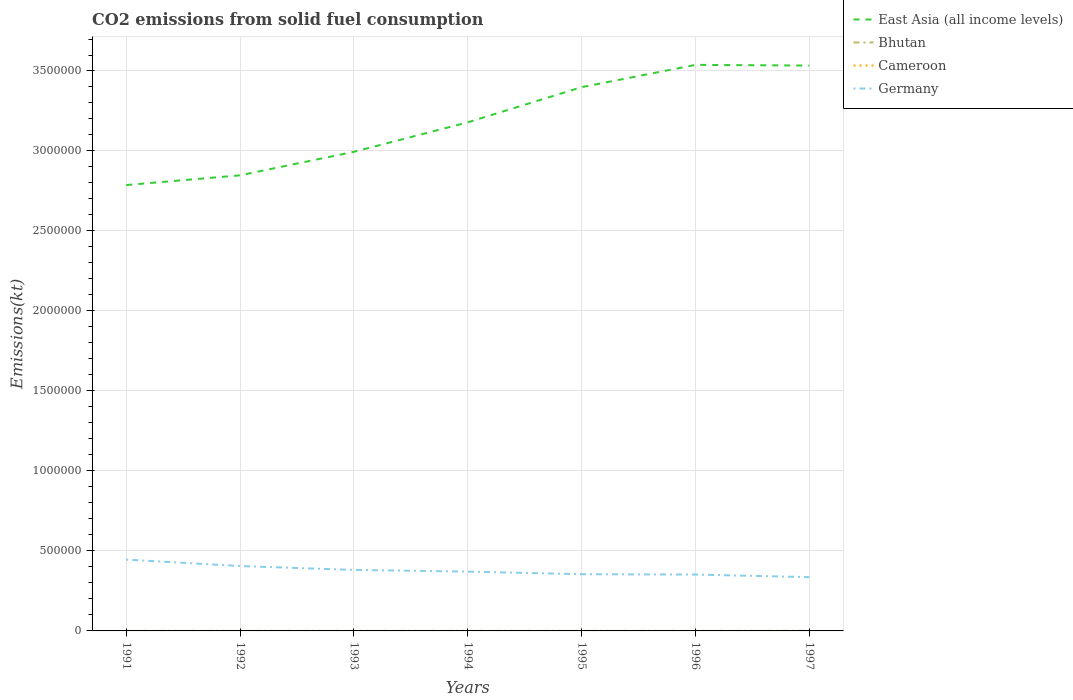Does the line corresponding to Cameroon intersect with the line corresponding to Bhutan?
Provide a short and direct response. No. Is the number of lines equal to the number of legend labels?
Provide a succinct answer. Yes. Across all years, what is the maximum amount of CO2 emitted in Cameroon?
Ensure brevity in your answer.  3.67. What is the total amount of CO2 emitted in Germany in the graph?
Your response must be concise. 2.67e+04. What is the difference between the highest and the second highest amount of CO2 emitted in Cameroon?
Ensure brevity in your answer.  0. Is the amount of CO2 emitted in Cameroon strictly greater than the amount of CO2 emitted in Germany over the years?
Offer a very short reply. Yes. How many lines are there?
Offer a very short reply. 4. What is the difference between two consecutive major ticks on the Y-axis?
Offer a very short reply. 5.00e+05. Does the graph contain any zero values?
Your answer should be very brief. No. Does the graph contain grids?
Your answer should be compact. Yes. What is the title of the graph?
Offer a very short reply. CO2 emissions from solid fuel consumption. Does "Guinea" appear as one of the legend labels in the graph?
Give a very brief answer. No. What is the label or title of the Y-axis?
Give a very brief answer. Emissions(kt). What is the Emissions(kt) in East Asia (all income levels) in 1991?
Your answer should be compact. 2.79e+06. What is the Emissions(kt) in Bhutan in 1991?
Offer a very short reply. 47.67. What is the Emissions(kt) of Cameroon in 1991?
Provide a succinct answer. 3.67. What is the Emissions(kt) in Germany in 1991?
Ensure brevity in your answer.  4.46e+05. What is the Emissions(kt) of East Asia (all income levels) in 1992?
Your response must be concise. 2.85e+06. What is the Emissions(kt) in Bhutan in 1992?
Your answer should be compact. 80.67. What is the Emissions(kt) in Cameroon in 1992?
Ensure brevity in your answer.  3.67. What is the Emissions(kt) of Germany in 1992?
Ensure brevity in your answer.  4.06e+05. What is the Emissions(kt) of East Asia (all income levels) in 1993?
Make the answer very short. 3.00e+06. What is the Emissions(kt) in Bhutan in 1993?
Your answer should be compact. 44. What is the Emissions(kt) in Cameroon in 1993?
Provide a short and direct response. 3.67. What is the Emissions(kt) of Germany in 1993?
Provide a succinct answer. 3.81e+05. What is the Emissions(kt) of East Asia (all income levels) in 1994?
Give a very brief answer. 3.18e+06. What is the Emissions(kt) in Bhutan in 1994?
Give a very brief answer. 62.34. What is the Emissions(kt) of Cameroon in 1994?
Offer a terse response. 3.67. What is the Emissions(kt) in Germany in 1994?
Keep it short and to the point. 3.71e+05. What is the Emissions(kt) in East Asia (all income levels) in 1995?
Offer a very short reply. 3.40e+06. What is the Emissions(kt) in Bhutan in 1995?
Offer a terse response. 77.01. What is the Emissions(kt) of Cameroon in 1995?
Make the answer very short. 3.67. What is the Emissions(kt) of Germany in 1995?
Offer a very short reply. 3.55e+05. What is the Emissions(kt) of East Asia (all income levels) in 1996?
Your answer should be compact. 3.54e+06. What is the Emissions(kt) of Bhutan in 1996?
Give a very brief answer. 91.67. What is the Emissions(kt) in Cameroon in 1996?
Keep it short and to the point. 3.67. What is the Emissions(kt) in Germany in 1996?
Make the answer very short. 3.52e+05. What is the Emissions(kt) in East Asia (all income levels) in 1997?
Ensure brevity in your answer.  3.53e+06. What is the Emissions(kt) of Bhutan in 1997?
Make the answer very short. 187.02. What is the Emissions(kt) in Cameroon in 1997?
Give a very brief answer. 3.67. What is the Emissions(kt) in Germany in 1997?
Keep it short and to the point. 3.36e+05. Across all years, what is the maximum Emissions(kt) of East Asia (all income levels)?
Give a very brief answer. 3.54e+06. Across all years, what is the maximum Emissions(kt) of Bhutan?
Your response must be concise. 187.02. Across all years, what is the maximum Emissions(kt) in Cameroon?
Offer a terse response. 3.67. Across all years, what is the maximum Emissions(kt) of Germany?
Offer a terse response. 4.46e+05. Across all years, what is the minimum Emissions(kt) in East Asia (all income levels)?
Offer a very short reply. 2.79e+06. Across all years, what is the minimum Emissions(kt) of Bhutan?
Your response must be concise. 44. Across all years, what is the minimum Emissions(kt) of Cameroon?
Your answer should be very brief. 3.67. Across all years, what is the minimum Emissions(kt) in Germany?
Your answer should be very brief. 3.36e+05. What is the total Emissions(kt) of East Asia (all income levels) in the graph?
Give a very brief answer. 2.23e+07. What is the total Emissions(kt) of Bhutan in the graph?
Make the answer very short. 590.39. What is the total Emissions(kt) of Cameroon in the graph?
Give a very brief answer. 25.67. What is the total Emissions(kt) of Germany in the graph?
Ensure brevity in your answer.  2.65e+06. What is the difference between the Emissions(kt) of East Asia (all income levels) in 1991 and that in 1992?
Your response must be concise. -6.08e+04. What is the difference between the Emissions(kt) in Bhutan in 1991 and that in 1992?
Offer a very short reply. -33. What is the difference between the Emissions(kt) of Germany in 1991 and that in 1992?
Your answer should be very brief. 4.02e+04. What is the difference between the Emissions(kt) in East Asia (all income levels) in 1991 and that in 1993?
Offer a very short reply. -2.08e+05. What is the difference between the Emissions(kt) of Bhutan in 1991 and that in 1993?
Keep it short and to the point. 3.67. What is the difference between the Emissions(kt) of Germany in 1991 and that in 1993?
Your response must be concise. 6.46e+04. What is the difference between the Emissions(kt) in East Asia (all income levels) in 1991 and that in 1994?
Make the answer very short. -3.92e+05. What is the difference between the Emissions(kt) of Bhutan in 1991 and that in 1994?
Give a very brief answer. -14.67. What is the difference between the Emissions(kt) in Germany in 1991 and that in 1994?
Your answer should be very brief. 7.50e+04. What is the difference between the Emissions(kt) of East Asia (all income levels) in 1991 and that in 1995?
Provide a succinct answer. -6.12e+05. What is the difference between the Emissions(kt) of Bhutan in 1991 and that in 1995?
Provide a short and direct response. -29.34. What is the difference between the Emissions(kt) in Cameroon in 1991 and that in 1995?
Your answer should be very brief. 0. What is the difference between the Emissions(kt) in Germany in 1991 and that in 1995?
Make the answer very short. 9.13e+04. What is the difference between the Emissions(kt) of East Asia (all income levels) in 1991 and that in 1996?
Provide a succinct answer. -7.51e+05. What is the difference between the Emissions(kt) of Bhutan in 1991 and that in 1996?
Provide a succinct answer. -44. What is the difference between the Emissions(kt) of Germany in 1991 and that in 1996?
Provide a short and direct response. 9.35e+04. What is the difference between the Emissions(kt) of East Asia (all income levels) in 1991 and that in 1997?
Provide a short and direct response. -7.47e+05. What is the difference between the Emissions(kt) of Bhutan in 1991 and that in 1997?
Provide a succinct answer. -139.35. What is the difference between the Emissions(kt) in Germany in 1991 and that in 1997?
Offer a very short reply. 1.10e+05. What is the difference between the Emissions(kt) in East Asia (all income levels) in 1992 and that in 1993?
Give a very brief answer. -1.47e+05. What is the difference between the Emissions(kt) in Bhutan in 1992 and that in 1993?
Offer a terse response. 36.67. What is the difference between the Emissions(kt) in Cameroon in 1992 and that in 1993?
Your answer should be very brief. 0. What is the difference between the Emissions(kt) of Germany in 1992 and that in 1993?
Your answer should be very brief. 2.44e+04. What is the difference between the Emissions(kt) of East Asia (all income levels) in 1992 and that in 1994?
Your response must be concise. -3.31e+05. What is the difference between the Emissions(kt) in Bhutan in 1992 and that in 1994?
Provide a short and direct response. 18.34. What is the difference between the Emissions(kt) in Germany in 1992 and that in 1994?
Your response must be concise. 3.48e+04. What is the difference between the Emissions(kt) in East Asia (all income levels) in 1992 and that in 1995?
Your answer should be very brief. -5.51e+05. What is the difference between the Emissions(kt) of Bhutan in 1992 and that in 1995?
Your answer should be compact. 3.67. What is the difference between the Emissions(kt) in Cameroon in 1992 and that in 1995?
Provide a succinct answer. 0. What is the difference between the Emissions(kt) of Germany in 1992 and that in 1995?
Offer a terse response. 5.10e+04. What is the difference between the Emissions(kt) of East Asia (all income levels) in 1992 and that in 1996?
Offer a very short reply. -6.90e+05. What is the difference between the Emissions(kt) of Bhutan in 1992 and that in 1996?
Keep it short and to the point. -11. What is the difference between the Emissions(kt) of Cameroon in 1992 and that in 1996?
Your answer should be compact. 0. What is the difference between the Emissions(kt) in Germany in 1992 and that in 1996?
Make the answer very short. 5.33e+04. What is the difference between the Emissions(kt) of East Asia (all income levels) in 1992 and that in 1997?
Keep it short and to the point. -6.86e+05. What is the difference between the Emissions(kt) of Bhutan in 1992 and that in 1997?
Your response must be concise. -106.34. What is the difference between the Emissions(kt) in Cameroon in 1992 and that in 1997?
Provide a short and direct response. 0. What is the difference between the Emissions(kt) in Germany in 1992 and that in 1997?
Make the answer very short. 6.94e+04. What is the difference between the Emissions(kt) in East Asia (all income levels) in 1993 and that in 1994?
Offer a very short reply. -1.84e+05. What is the difference between the Emissions(kt) of Bhutan in 1993 and that in 1994?
Your answer should be compact. -18.34. What is the difference between the Emissions(kt) of Cameroon in 1993 and that in 1994?
Provide a succinct answer. 0. What is the difference between the Emissions(kt) of Germany in 1993 and that in 1994?
Your answer should be very brief. 1.04e+04. What is the difference between the Emissions(kt) of East Asia (all income levels) in 1993 and that in 1995?
Offer a very short reply. -4.04e+05. What is the difference between the Emissions(kt) in Bhutan in 1993 and that in 1995?
Offer a very short reply. -33. What is the difference between the Emissions(kt) in Germany in 1993 and that in 1995?
Ensure brevity in your answer.  2.67e+04. What is the difference between the Emissions(kt) of East Asia (all income levels) in 1993 and that in 1996?
Provide a short and direct response. -5.43e+05. What is the difference between the Emissions(kt) in Bhutan in 1993 and that in 1996?
Offer a terse response. -47.67. What is the difference between the Emissions(kt) of Cameroon in 1993 and that in 1996?
Your answer should be very brief. 0. What is the difference between the Emissions(kt) in Germany in 1993 and that in 1996?
Provide a succinct answer. 2.89e+04. What is the difference between the Emissions(kt) of East Asia (all income levels) in 1993 and that in 1997?
Provide a succinct answer. -5.39e+05. What is the difference between the Emissions(kt) in Bhutan in 1993 and that in 1997?
Your answer should be compact. -143.01. What is the difference between the Emissions(kt) in Cameroon in 1993 and that in 1997?
Provide a short and direct response. 0. What is the difference between the Emissions(kt) of Germany in 1993 and that in 1997?
Provide a short and direct response. 4.51e+04. What is the difference between the Emissions(kt) of East Asia (all income levels) in 1994 and that in 1995?
Your answer should be very brief. -2.20e+05. What is the difference between the Emissions(kt) of Bhutan in 1994 and that in 1995?
Your response must be concise. -14.67. What is the difference between the Emissions(kt) in Germany in 1994 and that in 1995?
Ensure brevity in your answer.  1.62e+04. What is the difference between the Emissions(kt) in East Asia (all income levels) in 1994 and that in 1996?
Keep it short and to the point. -3.59e+05. What is the difference between the Emissions(kt) in Bhutan in 1994 and that in 1996?
Offer a very short reply. -29.34. What is the difference between the Emissions(kt) of Germany in 1994 and that in 1996?
Your response must be concise. 1.85e+04. What is the difference between the Emissions(kt) of East Asia (all income levels) in 1994 and that in 1997?
Offer a very short reply. -3.55e+05. What is the difference between the Emissions(kt) of Bhutan in 1994 and that in 1997?
Ensure brevity in your answer.  -124.68. What is the difference between the Emissions(kt) of Germany in 1994 and that in 1997?
Your response must be concise. 3.46e+04. What is the difference between the Emissions(kt) in East Asia (all income levels) in 1995 and that in 1996?
Provide a short and direct response. -1.39e+05. What is the difference between the Emissions(kt) in Bhutan in 1995 and that in 1996?
Your answer should be very brief. -14.67. What is the difference between the Emissions(kt) of Germany in 1995 and that in 1996?
Ensure brevity in your answer.  2244.2. What is the difference between the Emissions(kt) in East Asia (all income levels) in 1995 and that in 1997?
Provide a succinct answer. -1.35e+05. What is the difference between the Emissions(kt) of Bhutan in 1995 and that in 1997?
Make the answer very short. -110.01. What is the difference between the Emissions(kt) in Germany in 1995 and that in 1997?
Your answer should be compact. 1.84e+04. What is the difference between the Emissions(kt) of East Asia (all income levels) in 1996 and that in 1997?
Your answer should be compact. 4301.22. What is the difference between the Emissions(kt) in Bhutan in 1996 and that in 1997?
Your answer should be very brief. -95.34. What is the difference between the Emissions(kt) of Germany in 1996 and that in 1997?
Give a very brief answer. 1.62e+04. What is the difference between the Emissions(kt) in East Asia (all income levels) in 1991 and the Emissions(kt) in Bhutan in 1992?
Your answer should be very brief. 2.79e+06. What is the difference between the Emissions(kt) of East Asia (all income levels) in 1991 and the Emissions(kt) of Cameroon in 1992?
Offer a very short reply. 2.79e+06. What is the difference between the Emissions(kt) in East Asia (all income levels) in 1991 and the Emissions(kt) in Germany in 1992?
Provide a short and direct response. 2.38e+06. What is the difference between the Emissions(kt) of Bhutan in 1991 and the Emissions(kt) of Cameroon in 1992?
Your answer should be compact. 44. What is the difference between the Emissions(kt) in Bhutan in 1991 and the Emissions(kt) in Germany in 1992?
Your response must be concise. -4.06e+05. What is the difference between the Emissions(kt) in Cameroon in 1991 and the Emissions(kt) in Germany in 1992?
Provide a succinct answer. -4.06e+05. What is the difference between the Emissions(kt) of East Asia (all income levels) in 1991 and the Emissions(kt) of Bhutan in 1993?
Offer a terse response. 2.79e+06. What is the difference between the Emissions(kt) of East Asia (all income levels) in 1991 and the Emissions(kt) of Cameroon in 1993?
Keep it short and to the point. 2.79e+06. What is the difference between the Emissions(kt) in East Asia (all income levels) in 1991 and the Emissions(kt) in Germany in 1993?
Your answer should be very brief. 2.41e+06. What is the difference between the Emissions(kt) in Bhutan in 1991 and the Emissions(kt) in Cameroon in 1993?
Your answer should be very brief. 44. What is the difference between the Emissions(kt) of Bhutan in 1991 and the Emissions(kt) of Germany in 1993?
Your response must be concise. -3.81e+05. What is the difference between the Emissions(kt) of Cameroon in 1991 and the Emissions(kt) of Germany in 1993?
Offer a terse response. -3.81e+05. What is the difference between the Emissions(kt) of East Asia (all income levels) in 1991 and the Emissions(kt) of Bhutan in 1994?
Give a very brief answer. 2.79e+06. What is the difference between the Emissions(kt) in East Asia (all income levels) in 1991 and the Emissions(kt) in Cameroon in 1994?
Provide a succinct answer. 2.79e+06. What is the difference between the Emissions(kt) of East Asia (all income levels) in 1991 and the Emissions(kt) of Germany in 1994?
Keep it short and to the point. 2.42e+06. What is the difference between the Emissions(kt) of Bhutan in 1991 and the Emissions(kt) of Cameroon in 1994?
Your response must be concise. 44. What is the difference between the Emissions(kt) in Bhutan in 1991 and the Emissions(kt) in Germany in 1994?
Your answer should be compact. -3.71e+05. What is the difference between the Emissions(kt) of Cameroon in 1991 and the Emissions(kt) of Germany in 1994?
Your response must be concise. -3.71e+05. What is the difference between the Emissions(kt) in East Asia (all income levels) in 1991 and the Emissions(kt) in Bhutan in 1995?
Give a very brief answer. 2.79e+06. What is the difference between the Emissions(kt) in East Asia (all income levels) in 1991 and the Emissions(kt) in Cameroon in 1995?
Your answer should be very brief. 2.79e+06. What is the difference between the Emissions(kt) of East Asia (all income levels) in 1991 and the Emissions(kt) of Germany in 1995?
Offer a very short reply. 2.43e+06. What is the difference between the Emissions(kt) in Bhutan in 1991 and the Emissions(kt) in Cameroon in 1995?
Keep it short and to the point. 44. What is the difference between the Emissions(kt) in Bhutan in 1991 and the Emissions(kt) in Germany in 1995?
Offer a terse response. -3.54e+05. What is the difference between the Emissions(kt) of Cameroon in 1991 and the Emissions(kt) of Germany in 1995?
Offer a terse response. -3.55e+05. What is the difference between the Emissions(kt) in East Asia (all income levels) in 1991 and the Emissions(kt) in Bhutan in 1996?
Make the answer very short. 2.79e+06. What is the difference between the Emissions(kt) in East Asia (all income levels) in 1991 and the Emissions(kt) in Cameroon in 1996?
Offer a very short reply. 2.79e+06. What is the difference between the Emissions(kt) in East Asia (all income levels) in 1991 and the Emissions(kt) in Germany in 1996?
Your answer should be very brief. 2.43e+06. What is the difference between the Emissions(kt) of Bhutan in 1991 and the Emissions(kt) of Cameroon in 1996?
Your answer should be very brief. 44. What is the difference between the Emissions(kt) of Bhutan in 1991 and the Emissions(kt) of Germany in 1996?
Offer a terse response. -3.52e+05. What is the difference between the Emissions(kt) of Cameroon in 1991 and the Emissions(kt) of Germany in 1996?
Offer a very short reply. -3.52e+05. What is the difference between the Emissions(kt) of East Asia (all income levels) in 1991 and the Emissions(kt) of Bhutan in 1997?
Offer a terse response. 2.79e+06. What is the difference between the Emissions(kt) of East Asia (all income levels) in 1991 and the Emissions(kt) of Cameroon in 1997?
Provide a succinct answer. 2.79e+06. What is the difference between the Emissions(kt) in East Asia (all income levels) in 1991 and the Emissions(kt) in Germany in 1997?
Your answer should be very brief. 2.45e+06. What is the difference between the Emissions(kt) of Bhutan in 1991 and the Emissions(kt) of Cameroon in 1997?
Offer a very short reply. 44. What is the difference between the Emissions(kt) in Bhutan in 1991 and the Emissions(kt) in Germany in 1997?
Offer a terse response. -3.36e+05. What is the difference between the Emissions(kt) in Cameroon in 1991 and the Emissions(kt) in Germany in 1997?
Your answer should be compact. -3.36e+05. What is the difference between the Emissions(kt) of East Asia (all income levels) in 1992 and the Emissions(kt) of Bhutan in 1993?
Provide a succinct answer. 2.85e+06. What is the difference between the Emissions(kt) of East Asia (all income levels) in 1992 and the Emissions(kt) of Cameroon in 1993?
Your answer should be compact. 2.85e+06. What is the difference between the Emissions(kt) of East Asia (all income levels) in 1992 and the Emissions(kt) of Germany in 1993?
Ensure brevity in your answer.  2.47e+06. What is the difference between the Emissions(kt) in Bhutan in 1992 and the Emissions(kt) in Cameroon in 1993?
Your answer should be compact. 77.01. What is the difference between the Emissions(kt) of Bhutan in 1992 and the Emissions(kt) of Germany in 1993?
Provide a succinct answer. -3.81e+05. What is the difference between the Emissions(kt) in Cameroon in 1992 and the Emissions(kt) in Germany in 1993?
Offer a very short reply. -3.81e+05. What is the difference between the Emissions(kt) of East Asia (all income levels) in 1992 and the Emissions(kt) of Bhutan in 1994?
Give a very brief answer. 2.85e+06. What is the difference between the Emissions(kt) of East Asia (all income levels) in 1992 and the Emissions(kt) of Cameroon in 1994?
Make the answer very short. 2.85e+06. What is the difference between the Emissions(kt) in East Asia (all income levels) in 1992 and the Emissions(kt) in Germany in 1994?
Make the answer very short. 2.48e+06. What is the difference between the Emissions(kt) in Bhutan in 1992 and the Emissions(kt) in Cameroon in 1994?
Your answer should be compact. 77.01. What is the difference between the Emissions(kt) of Bhutan in 1992 and the Emissions(kt) of Germany in 1994?
Offer a terse response. -3.71e+05. What is the difference between the Emissions(kt) of Cameroon in 1992 and the Emissions(kt) of Germany in 1994?
Offer a very short reply. -3.71e+05. What is the difference between the Emissions(kt) in East Asia (all income levels) in 1992 and the Emissions(kt) in Bhutan in 1995?
Offer a very short reply. 2.85e+06. What is the difference between the Emissions(kt) of East Asia (all income levels) in 1992 and the Emissions(kt) of Cameroon in 1995?
Give a very brief answer. 2.85e+06. What is the difference between the Emissions(kt) in East Asia (all income levels) in 1992 and the Emissions(kt) in Germany in 1995?
Offer a terse response. 2.49e+06. What is the difference between the Emissions(kt) in Bhutan in 1992 and the Emissions(kt) in Cameroon in 1995?
Ensure brevity in your answer.  77.01. What is the difference between the Emissions(kt) of Bhutan in 1992 and the Emissions(kt) of Germany in 1995?
Offer a terse response. -3.54e+05. What is the difference between the Emissions(kt) in Cameroon in 1992 and the Emissions(kt) in Germany in 1995?
Your answer should be very brief. -3.55e+05. What is the difference between the Emissions(kt) in East Asia (all income levels) in 1992 and the Emissions(kt) in Bhutan in 1996?
Make the answer very short. 2.85e+06. What is the difference between the Emissions(kt) of East Asia (all income levels) in 1992 and the Emissions(kt) of Cameroon in 1996?
Provide a short and direct response. 2.85e+06. What is the difference between the Emissions(kt) of East Asia (all income levels) in 1992 and the Emissions(kt) of Germany in 1996?
Give a very brief answer. 2.50e+06. What is the difference between the Emissions(kt) in Bhutan in 1992 and the Emissions(kt) in Cameroon in 1996?
Provide a succinct answer. 77.01. What is the difference between the Emissions(kt) in Bhutan in 1992 and the Emissions(kt) in Germany in 1996?
Your answer should be very brief. -3.52e+05. What is the difference between the Emissions(kt) of Cameroon in 1992 and the Emissions(kt) of Germany in 1996?
Offer a terse response. -3.52e+05. What is the difference between the Emissions(kt) in East Asia (all income levels) in 1992 and the Emissions(kt) in Bhutan in 1997?
Your response must be concise. 2.85e+06. What is the difference between the Emissions(kt) in East Asia (all income levels) in 1992 and the Emissions(kt) in Cameroon in 1997?
Your answer should be compact. 2.85e+06. What is the difference between the Emissions(kt) in East Asia (all income levels) in 1992 and the Emissions(kt) in Germany in 1997?
Ensure brevity in your answer.  2.51e+06. What is the difference between the Emissions(kt) of Bhutan in 1992 and the Emissions(kt) of Cameroon in 1997?
Make the answer very short. 77.01. What is the difference between the Emissions(kt) of Bhutan in 1992 and the Emissions(kt) of Germany in 1997?
Your answer should be compact. -3.36e+05. What is the difference between the Emissions(kt) of Cameroon in 1992 and the Emissions(kt) of Germany in 1997?
Give a very brief answer. -3.36e+05. What is the difference between the Emissions(kt) in East Asia (all income levels) in 1993 and the Emissions(kt) in Bhutan in 1994?
Your response must be concise. 2.99e+06. What is the difference between the Emissions(kt) of East Asia (all income levels) in 1993 and the Emissions(kt) of Cameroon in 1994?
Your answer should be very brief. 2.99e+06. What is the difference between the Emissions(kt) in East Asia (all income levels) in 1993 and the Emissions(kt) in Germany in 1994?
Offer a very short reply. 2.62e+06. What is the difference between the Emissions(kt) of Bhutan in 1993 and the Emissions(kt) of Cameroon in 1994?
Make the answer very short. 40.34. What is the difference between the Emissions(kt) in Bhutan in 1993 and the Emissions(kt) in Germany in 1994?
Your response must be concise. -3.71e+05. What is the difference between the Emissions(kt) of Cameroon in 1993 and the Emissions(kt) of Germany in 1994?
Offer a very short reply. -3.71e+05. What is the difference between the Emissions(kt) of East Asia (all income levels) in 1993 and the Emissions(kt) of Bhutan in 1995?
Make the answer very short. 2.99e+06. What is the difference between the Emissions(kt) in East Asia (all income levels) in 1993 and the Emissions(kt) in Cameroon in 1995?
Give a very brief answer. 2.99e+06. What is the difference between the Emissions(kt) of East Asia (all income levels) in 1993 and the Emissions(kt) of Germany in 1995?
Offer a very short reply. 2.64e+06. What is the difference between the Emissions(kt) of Bhutan in 1993 and the Emissions(kt) of Cameroon in 1995?
Ensure brevity in your answer.  40.34. What is the difference between the Emissions(kt) in Bhutan in 1993 and the Emissions(kt) in Germany in 1995?
Offer a very short reply. -3.54e+05. What is the difference between the Emissions(kt) in Cameroon in 1993 and the Emissions(kt) in Germany in 1995?
Make the answer very short. -3.55e+05. What is the difference between the Emissions(kt) in East Asia (all income levels) in 1993 and the Emissions(kt) in Bhutan in 1996?
Keep it short and to the point. 2.99e+06. What is the difference between the Emissions(kt) of East Asia (all income levels) in 1993 and the Emissions(kt) of Cameroon in 1996?
Ensure brevity in your answer.  2.99e+06. What is the difference between the Emissions(kt) of East Asia (all income levels) in 1993 and the Emissions(kt) of Germany in 1996?
Your answer should be very brief. 2.64e+06. What is the difference between the Emissions(kt) in Bhutan in 1993 and the Emissions(kt) in Cameroon in 1996?
Provide a short and direct response. 40.34. What is the difference between the Emissions(kt) in Bhutan in 1993 and the Emissions(kt) in Germany in 1996?
Make the answer very short. -3.52e+05. What is the difference between the Emissions(kt) of Cameroon in 1993 and the Emissions(kt) of Germany in 1996?
Offer a terse response. -3.52e+05. What is the difference between the Emissions(kt) of East Asia (all income levels) in 1993 and the Emissions(kt) of Bhutan in 1997?
Your answer should be compact. 2.99e+06. What is the difference between the Emissions(kt) in East Asia (all income levels) in 1993 and the Emissions(kt) in Cameroon in 1997?
Offer a terse response. 2.99e+06. What is the difference between the Emissions(kt) of East Asia (all income levels) in 1993 and the Emissions(kt) of Germany in 1997?
Make the answer very short. 2.66e+06. What is the difference between the Emissions(kt) in Bhutan in 1993 and the Emissions(kt) in Cameroon in 1997?
Make the answer very short. 40.34. What is the difference between the Emissions(kt) of Bhutan in 1993 and the Emissions(kt) of Germany in 1997?
Your answer should be very brief. -3.36e+05. What is the difference between the Emissions(kt) in Cameroon in 1993 and the Emissions(kt) in Germany in 1997?
Give a very brief answer. -3.36e+05. What is the difference between the Emissions(kt) of East Asia (all income levels) in 1994 and the Emissions(kt) of Bhutan in 1995?
Your answer should be compact. 3.18e+06. What is the difference between the Emissions(kt) in East Asia (all income levels) in 1994 and the Emissions(kt) in Cameroon in 1995?
Your answer should be very brief. 3.18e+06. What is the difference between the Emissions(kt) in East Asia (all income levels) in 1994 and the Emissions(kt) in Germany in 1995?
Keep it short and to the point. 2.82e+06. What is the difference between the Emissions(kt) of Bhutan in 1994 and the Emissions(kt) of Cameroon in 1995?
Give a very brief answer. 58.67. What is the difference between the Emissions(kt) in Bhutan in 1994 and the Emissions(kt) in Germany in 1995?
Keep it short and to the point. -3.54e+05. What is the difference between the Emissions(kt) of Cameroon in 1994 and the Emissions(kt) of Germany in 1995?
Make the answer very short. -3.55e+05. What is the difference between the Emissions(kt) of East Asia (all income levels) in 1994 and the Emissions(kt) of Bhutan in 1996?
Offer a terse response. 3.18e+06. What is the difference between the Emissions(kt) in East Asia (all income levels) in 1994 and the Emissions(kt) in Cameroon in 1996?
Give a very brief answer. 3.18e+06. What is the difference between the Emissions(kt) of East Asia (all income levels) in 1994 and the Emissions(kt) of Germany in 1996?
Your answer should be compact. 2.83e+06. What is the difference between the Emissions(kt) of Bhutan in 1994 and the Emissions(kt) of Cameroon in 1996?
Offer a very short reply. 58.67. What is the difference between the Emissions(kt) in Bhutan in 1994 and the Emissions(kt) in Germany in 1996?
Keep it short and to the point. -3.52e+05. What is the difference between the Emissions(kt) of Cameroon in 1994 and the Emissions(kt) of Germany in 1996?
Provide a succinct answer. -3.52e+05. What is the difference between the Emissions(kt) in East Asia (all income levels) in 1994 and the Emissions(kt) in Bhutan in 1997?
Your response must be concise. 3.18e+06. What is the difference between the Emissions(kt) of East Asia (all income levels) in 1994 and the Emissions(kt) of Cameroon in 1997?
Give a very brief answer. 3.18e+06. What is the difference between the Emissions(kt) in East Asia (all income levels) in 1994 and the Emissions(kt) in Germany in 1997?
Your answer should be compact. 2.84e+06. What is the difference between the Emissions(kt) of Bhutan in 1994 and the Emissions(kt) of Cameroon in 1997?
Make the answer very short. 58.67. What is the difference between the Emissions(kt) in Bhutan in 1994 and the Emissions(kt) in Germany in 1997?
Your answer should be very brief. -3.36e+05. What is the difference between the Emissions(kt) in Cameroon in 1994 and the Emissions(kt) in Germany in 1997?
Keep it short and to the point. -3.36e+05. What is the difference between the Emissions(kt) of East Asia (all income levels) in 1995 and the Emissions(kt) of Bhutan in 1996?
Make the answer very short. 3.40e+06. What is the difference between the Emissions(kt) of East Asia (all income levels) in 1995 and the Emissions(kt) of Cameroon in 1996?
Your response must be concise. 3.40e+06. What is the difference between the Emissions(kt) of East Asia (all income levels) in 1995 and the Emissions(kt) of Germany in 1996?
Offer a terse response. 3.05e+06. What is the difference between the Emissions(kt) of Bhutan in 1995 and the Emissions(kt) of Cameroon in 1996?
Keep it short and to the point. 73.34. What is the difference between the Emissions(kt) in Bhutan in 1995 and the Emissions(kt) in Germany in 1996?
Your answer should be compact. -3.52e+05. What is the difference between the Emissions(kt) in Cameroon in 1995 and the Emissions(kt) in Germany in 1996?
Your answer should be very brief. -3.52e+05. What is the difference between the Emissions(kt) in East Asia (all income levels) in 1995 and the Emissions(kt) in Bhutan in 1997?
Offer a terse response. 3.40e+06. What is the difference between the Emissions(kt) in East Asia (all income levels) in 1995 and the Emissions(kt) in Cameroon in 1997?
Offer a terse response. 3.40e+06. What is the difference between the Emissions(kt) of East Asia (all income levels) in 1995 and the Emissions(kt) of Germany in 1997?
Offer a terse response. 3.06e+06. What is the difference between the Emissions(kt) of Bhutan in 1995 and the Emissions(kt) of Cameroon in 1997?
Offer a terse response. 73.34. What is the difference between the Emissions(kt) in Bhutan in 1995 and the Emissions(kt) in Germany in 1997?
Keep it short and to the point. -3.36e+05. What is the difference between the Emissions(kt) of Cameroon in 1995 and the Emissions(kt) of Germany in 1997?
Offer a very short reply. -3.36e+05. What is the difference between the Emissions(kt) of East Asia (all income levels) in 1996 and the Emissions(kt) of Bhutan in 1997?
Keep it short and to the point. 3.54e+06. What is the difference between the Emissions(kt) in East Asia (all income levels) in 1996 and the Emissions(kt) in Cameroon in 1997?
Provide a short and direct response. 3.54e+06. What is the difference between the Emissions(kt) in East Asia (all income levels) in 1996 and the Emissions(kt) in Germany in 1997?
Provide a succinct answer. 3.20e+06. What is the difference between the Emissions(kt) of Bhutan in 1996 and the Emissions(kt) of Cameroon in 1997?
Your answer should be compact. 88.01. What is the difference between the Emissions(kt) of Bhutan in 1996 and the Emissions(kt) of Germany in 1997?
Provide a succinct answer. -3.36e+05. What is the difference between the Emissions(kt) in Cameroon in 1996 and the Emissions(kt) in Germany in 1997?
Provide a succinct answer. -3.36e+05. What is the average Emissions(kt) of East Asia (all income levels) per year?
Make the answer very short. 3.18e+06. What is the average Emissions(kt) in Bhutan per year?
Provide a short and direct response. 84.34. What is the average Emissions(kt) in Cameroon per year?
Make the answer very short. 3.67. What is the average Emissions(kt) of Germany per year?
Offer a very short reply. 3.78e+05. In the year 1991, what is the difference between the Emissions(kt) of East Asia (all income levels) and Emissions(kt) of Bhutan?
Your response must be concise. 2.79e+06. In the year 1991, what is the difference between the Emissions(kt) in East Asia (all income levels) and Emissions(kt) in Cameroon?
Provide a short and direct response. 2.79e+06. In the year 1991, what is the difference between the Emissions(kt) of East Asia (all income levels) and Emissions(kt) of Germany?
Your response must be concise. 2.34e+06. In the year 1991, what is the difference between the Emissions(kt) in Bhutan and Emissions(kt) in Cameroon?
Offer a very short reply. 44. In the year 1991, what is the difference between the Emissions(kt) in Bhutan and Emissions(kt) in Germany?
Offer a very short reply. -4.46e+05. In the year 1991, what is the difference between the Emissions(kt) of Cameroon and Emissions(kt) of Germany?
Ensure brevity in your answer.  -4.46e+05. In the year 1992, what is the difference between the Emissions(kt) in East Asia (all income levels) and Emissions(kt) in Bhutan?
Give a very brief answer. 2.85e+06. In the year 1992, what is the difference between the Emissions(kt) of East Asia (all income levels) and Emissions(kt) of Cameroon?
Your answer should be very brief. 2.85e+06. In the year 1992, what is the difference between the Emissions(kt) of East Asia (all income levels) and Emissions(kt) of Germany?
Offer a terse response. 2.44e+06. In the year 1992, what is the difference between the Emissions(kt) in Bhutan and Emissions(kt) in Cameroon?
Provide a succinct answer. 77.01. In the year 1992, what is the difference between the Emissions(kt) in Bhutan and Emissions(kt) in Germany?
Your response must be concise. -4.05e+05. In the year 1992, what is the difference between the Emissions(kt) of Cameroon and Emissions(kt) of Germany?
Ensure brevity in your answer.  -4.06e+05. In the year 1993, what is the difference between the Emissions(kt) of East Asia (all income levels) and Emissions(kt) of Bhutan?
Offer a terse response. 2.99e+06. In the year 1993, what is the difference between the Emissions(kt) of East Asia (all income levels) and Emissions(kt) of Cameroon?
Give a very brief answer. 2.99e+06. In the year 1993, what is the difference between the Emissions(kt) in East Asia (all income levels) and Emissions(kt) in Germany?
Your answer should be very brief. 2.61e+06. In the year 1993, what is the difference between the Emissions(kt) in Bhutan and Emissions(kt) in Cameroon?
Provide a short and direct response. 40.34. In the year 1993, what is the difference between the Emissions(kt) of Bhutan and Emissions(kt) of Germany?
Give a very brief answer. -3.81e+05. In the year 1993, what is the difference between the Emissions(kt) in Cameroon and Emissions(kt) in Germany?
Ensure brevity in your answer.  -3.81e+05. In the year 1994, what is the difference between the Emissions(kt) of East Asia (all income levels) and Emissions(kt) of Bhutan?
Provide a succinct answer. 3.18e+06. In the year 1994, what is the difference between the Emissions(kt) of East Asia (all income levels) and Emissions(kt) of Cameroon?
Give a very brief answer. 3.18e+06. In the year 1994, what is the difference between the Emissions(kt) in East Asia (all income levels) and Emissions(kt) in Germany?
Keep it short and to the point. 2.81e+06. In the year 1994, what is the difference between the Emissions(kt) of Bhutan and Emissions(kt) of Cameroon?
Ensure brevity in your answer.  58.67. In the year 1994, what is the difference between the Emissions(kt) in Bhutan and Emissions(kt) in Germany?
Your answer should be compact. -3.71e+05. In the year 1994, what is the difference between the Emissions(kt) in Cameroon and Emissions(kt) in Germany?
Offer a very short reply. -3.71e+05. In the year 1995, what is the difference between the Emissions(kt) of East Asia (all income levels) and Emissions(kt) of Bhutan?
Your answer should be very brief. 3.40e+06. In the year 1995, what is the difference between the Emissions(kt) in East Asia (all income levels) and Emissions(kt) in Cameroon?
Give a very brief answer. 3.40e+06. In the year 1995, what is the difference between the Emissions(kt) in East Asia (all income levels) and Emissions(kt) in Germany?
Provide a succinct answer. 3.04e+06. In the year 1995, what is the difference between the Emissions(kt) of Bhutan and Emissions(kt) of Cameroon?
Your answer should be very brief. 73.34. In the year 1995, what is the difference between the Emissions(kt) in Bhutan and Emissions(kt) in Germany?
Your response must be concise. -3.54e+05. In the year 1995, what is the difference between the Emissions(kt) in Cameroon and Emissions(kt) in Germany?
Your answer should be very brief. -3.55e+05. In the year 1996, what is the difference between the Emissions(kt) of East Asia (all income levels) and Emissions(kt) of Bhutan?
Provide a succinct answer. 3.54e+06. In the year 1996, what is the difference between the Emissions(kt) in East Asia (all income levels) and Emissions(kt) in Cameroon?
Give a very brief answer. 3.54e+06. In the year 1996, what is the difference between the Emissions(kt) of East Asia (all income levels) and Emissions(kt) of Germany?
Provide a succinct answer. 3.19e+06. In the year 1996, what is the difference between the Emissions(kt) in Bhutan and Emissions(kt) in Cameroon?
Give a very brief answer. 88.01. In the year 1996, what is the difference between the Emissions(kt) in Bhutan and Emissions(kt) in Germany?
Offer a terse response. -3.52e+05. In the year 1996, what is the difference between the Emissions(kt) of Cameroon and Emissions(kt) of Germany?
Offer a terse response. -3.52e+05. In the year 1997, what is the difference between the Emissions(kt) in East Asia (all income levels) and Emissions(kt) in Bhutan?
Provide a succinct answer. 3.53e+06. In the year 1997, what is the difference between the Emissions(kt) of East Asia (all income levels) and Emissions(kt) of Cameroon?
Your answer should be compact. 3.53e+06. In the year 1997, what is the difference between the Emissions(kt) in East Asia (all income levels) and Emissions(kt) in Germany?
Offer a terse response. 3.20e+06. In the year 1997, what is the difference between the Emissions(kt) in Bhutan and Emissions(kt) in Cameroon?
Your answer should be very brief. 183.35. In the year 1997, what is the difference between the Emissions(kt) in Bhutan and Emissions(kt) in Germany?
Your response must be concise. -3.36e+05. In the year 1997, what is the difference between the Emissions(kt) in Cameroon and Emissions(kt) in Germany?
Keep it short and to the point. -3.36e+05. What is the ratio of the Emissions(kt) of East Asia (all income levels) in 1991 to that in 1992?
Your answer should be compact. 0.98. What is the ratio of the Emissions(kt) of Bhutan in 1991 to that in 1992?
Provide a short and direct response. 0.59. What is the ratio of the Emissions(kt) in Germany in 1991 to that in 1992?
Provide a succinct answer. 1.1. What is the ratio of the Emissions(kt) in East Asia (all income levels) in 1991 to that in 1993?
Offer a very short reply. 0.93. What is the ratio of the Emissions(kt) of Bhutan in 1991 to that in 1993?
Provide a succinct answer. 1.08. What is the ratio of the Emissions(kt) in Cameroon in 1991 to that in 1993?
Offer a very short reply. 1. What is the ratio of the Emissions(kt) in Germany in 1991 to that in 1993?
Give a very brief answer. 1.17. What is the ratio of the Emissions(kt) of East Asia (all income levels) in 1991 to that in 1994?
Keep it short and to the point. 0.88. What is the ratio of the Emissions(kt) in Bhutan in 1991 to that in 1994?
Give a very brief answer. 0.76. What is the ratio of the Emissions(kt) in Germany in 1991 to that in 1994?
Offer a terse response. 1.2. What is the ratio of the Emissions(kt) of East Asia (all income levels) in 1991 to that in 1995?
Offer a terse response. 0.82. What is the ratio of the Emissions(kt) in Bhutan in 1991 to that in 1995?
Your answer should be very brief. 0.62. What is the ratio of the Emissions(kt) of Germany in 1991 to that in 1995?
Keep it short and to the point. 1.26. What is the ratio of the Emissions(kt) of East Asia (all income levels) in 1991 to that in 1996?
Offer a terse response. 0.79. What is the ratio of the Emissions(kt) of Bhutan in 1991 to that in 1996?
Make the answer very short. 0.52. What is the ratio of the Emissions(kt) in Cameroon in 1991 to that in 1996?
Offer a very short reply. 1. What is the ratio of the Emissions(kt) of Germany in 1991 to that in 1996?
Make the answer very short. 1.27. What is the ratio of the Emissions(kt) in East Asia (all income levels) in 1991 to that in 1997?
Keep it short and to the point. 0.79. What is the ratio of the Emissions(kt) in Bhutan in 1991 to that in 1997?
Keep it short and to the point. 0.25. What is the ratio of the Emissions(kt) of Germany in 1991 to that in 1997?
Keep it short and to the point. 1.33. What is the ratio of the Emissions(kt) of East Asia (all income levels) in 1992 to that in 1993?
Offer a terse response. 0.95. What is the ratio of the Emissions(kt) in Bhutan in 1992 to that in 1993?
Provide a succinct answer. 1.83. What is the ratio of the Emissions(kt) in Germany in 1992 to that in 1993?
Provide a succinct answer. 1.06. What is the ratio of the Emissions(kt) in East Asia (all income levels) in 1992 to that in 1994?
Make the answer very short. 0.9. What is the ratio of the Emissions(kt) of Bhutan in 1992 to that in 1994?
Offer a terse response. 1.29. What is the ratio of the Emissions(kt) in Germany in 1992 to that in 1994?
Keep it short and to the point. 1.09. What is the ratio of the Emissions(kt) in East Asia (all income levels) in 1992 to that in 1995?
Your answer should be very brief. 0.84. What is the ratio of the Emissions(kt) of Bhutan in 1992 to that in 1995?
Provide a short and direct response. 1.05. What is the ratio of the Emissions(kt) of Germany in 1992 to that in 1995?
Ensure brevity in your answer.  1.14. What is the ratio of the Emissions(kt) in East Asia (all income levels) in 1992 to that in 1996?
Keep it short and to the point. 0.8. What is the ratio of the Emissions(kt) in Germany in 1992 to that in 1996?
Offer a very short reply. 1.15. What is the ratio of the Emissions(kt) of East Asia (all income levels) in 1992 to that in 1997?
Make the answer very short. 0.81. What is the ratio of the Emissions(kt) in Bhutan in 1992 to that in 1997?
Your response must be concise. 0.43. What is the ratio of the Emissions(kt) of Germany in 1992 to that in 1997?
Offer a very short reply. 1.21. What is the ratio of the Emissions(kt) in East Asia (all income levels) in 1993 to that in 1994?
Offer a terse response. 0.94. What is the ratio of the Emissions(kt) in Bhutan in 1993 to that in 1994?
Keep it short and to the point. 0.71. What is the ratio of the Emissions(kt) in Germany in 1993 to that in 1994?
Ensure brevity in your answer.  1.03. What is the ratio of the Emissions(kt) of East Asia (all income levels) in 1993 to that in 1995?
Ensure brevity in your answer.  0.88. What is the ratio of the Emissions(kt) in Cameroon in 1993 to that in 1995?
Make the answer very short. 1. What is the ratio of the Emissions(kt) in Germany in 1993 to that in 1995?
Keep it short and to the point. 1.08. What is the ratio of the Emissions(kt) of East Asia (all income levels) in 1993 to that in 1996?
Your response must be concise. 0.85. What is the ratio of the Emissions(kt) in Bhutan in 1993 to that in 1996?
Your response must be concise. 0.48. What is the ratio of the Emissions(kt) in Cameroon in 1993 to that in 1996?
Offer a terse response. 1. What is the ratio of the Emissions(kt) of Germany in 1993 to that in 1996?
Your response must be concise. 1.08. What is the ratio of the Emissions(kt) in East Asia (all income levels) in 1993 to that in 1997?
Keep it short and to the point. 0.85. What is the ratio of the Emissions(kt) in Bhutan in 1993 to that in 1997?
Offer a terse response. 0.24. What is the ratio of the Emissions(kt) in Cameroon in 1993 to that in 1997?
Offer a terse response. 1. What is the ratio of the Emissions(kt) in Germany in 1993 to that in 1997?
Ensure brevity in your answer.  1.13. What is the ratio of the Emissions(kt) in East Asia (all income levels) in 1994 to that in 1995?
Ensure brevity in your answer.  0.94. What is the ratio of the Emissions(kt) in Bhutan in 1994 to that in 1995?
Keep it short and to the point. 0.81. What is the ratio of the Emissions(kt) of Cameroon in 1994 to that in 1995?
Give a very brief answer. 1. What is the ratio of the Emissions(kt) in Germany in 1994 to that in 1995?
Your answer should be very brief. 1.05. What is the ratio of the Emissions(kt) of East Asia (all income levels) in 1994 to that in 1996?
Provide a short and direct response. 0.9. What is the ratio of the Emissions(kt) of Bhutan in 1994 to that in 1996?
Give a very brief answer. 0.68. What is the ratio of the Emissions(kt) of Germany in 1994 to that in 1996?
Provide a short and direct response. 1.05. What is the ratio of the Emissions(kt) in East Asia (all income levels) in 1994 to that in 1997?
Make the answer very short. 0.9. What is the ratio of the Emissions(kt) of Bhutan in 1994 to that in 1997?
Provide a succinct answer. 0.33. What is the ratio of the Emissions(kt) in Cameroon in 1994 to that in 1997?
Make the answer very short. 1. What is the ratio of the Emissions(kt) of Germany in 1994 to that in 1997?
Keep it short and to the point. 1.1. What is the ratio of the Emissions(kt) in East Asia (all income levels) in 1995 to that in 1996?
Your response must be concise. 0.96. What is the ratio of the Emissions(kt) of Bhutan in 1995 to that in 1996?
Provide a short and direct response. 0.84. What is the ratio of the Emissions(kt) of Germany in 1995 to that in 1996?
Offer a very short reply. 1.01. What is the ratio of the Emissions(kt) of East Asia (all income levels) in 1995 to that in 1997?
Your answer should be very brief. 0.96. What is the ratio of the Emissions(kt) of Bhutan in 1995 to that in 1997?
Give a very brief answer. 0.41. What is the ratio of the Emissions(kt) in Cameroon in 1995 to that in 1997?
Provide a succinct answer. 1. What is the ratio of the Emissions(kt) of Germany in 1995 to that in 1997?
Provide a short and direct response. 1.05. What is the ratio of the Emissions(kt) of Bhutan in 1996 to that in 1997?
Provide a succinct answer. 0.49. What is the ratio of the Emissions(kt) of Cameroon in 1996 to that in 1997?
Provide a succinct answer. 1. What is the ratio of the Emissions(kt) in Germany in 1996 to that in 1997?
Give a very brief answer. 1.05. What is the difference between the highest and the second highest Emissions(kt) in East Asia (all income levels)?
Give a very brief answer. 4301.22. What is the difference between the highest and the second highest Emissions(kt) in Bhutan?
Offer a very short reply. 95.34. What is the difference between the highest and the second highest Emissions(kt) of Cameroon?
Offer a terse response. 0. What is the difference between the highest and the second highest Emissions(kt) of Germany?
Your response must be concise. 4.02e+04. What is the difference between the highest and the lowest Emissions(kt) of East Asia (all income levels)?
Provide a short and direct response. 7.51e+05. What is the difference between the highest and the lowest Emissions(kt) of Bhutan?
Offer a very short reply. 143.01. What is the difference between the highest and the lowest Emissions(kt) of Cameroon?
Offer a very short reply. 0. What is the difference between the highest and the lowest Emissions(kt) in Germany?
Offer a terse response. 1.10e+05. 